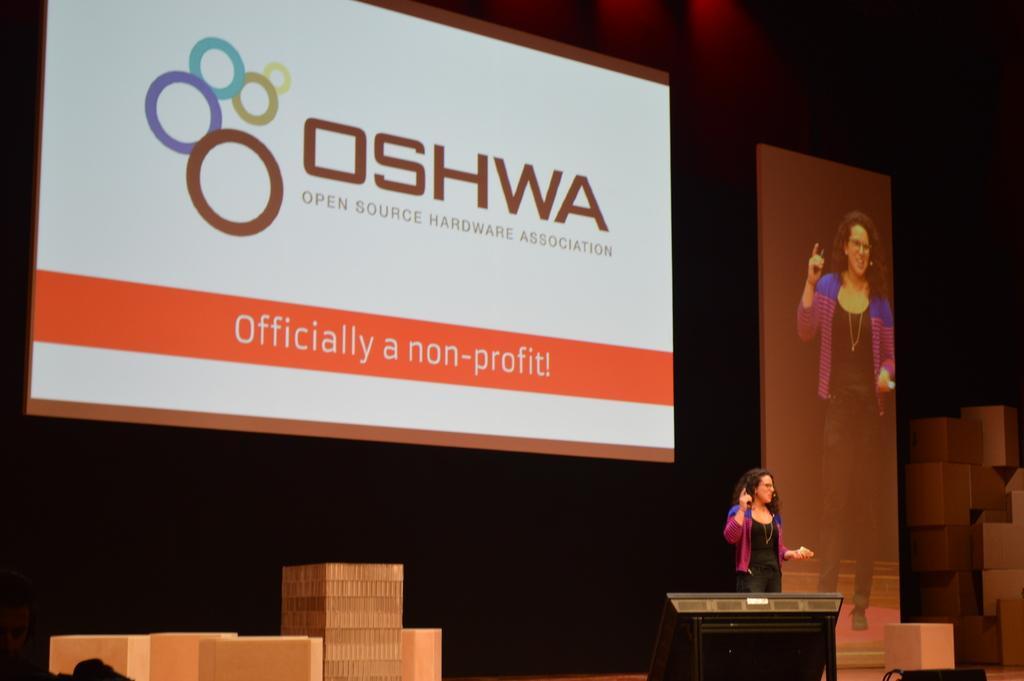Could you give a brief overview of what you see in this image? In this image there is one woman standing and talking, and in the background there are screens and some boxes. At the bottom there are some boxes and objects, and there is a black background. 